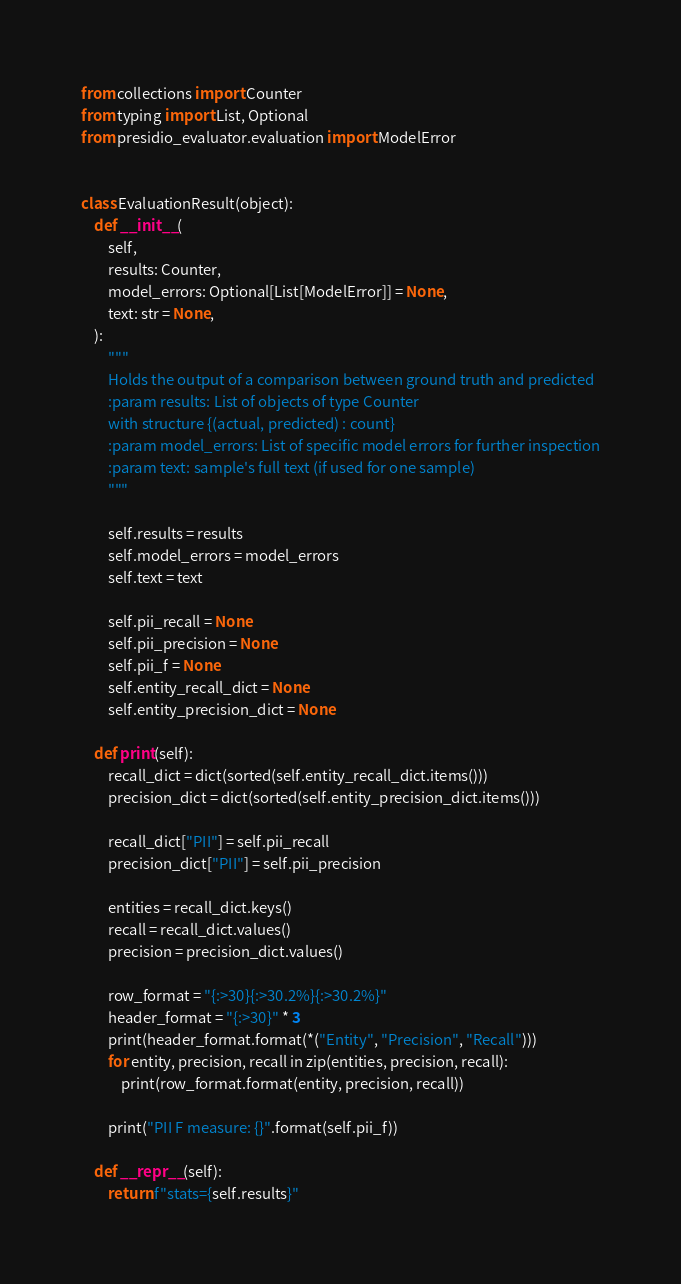Convert code to text. <code><loc_0><loc_0><loc_500><loc_500><_Python_>from collections import Counter
from typing import List, Optional
from presidio_evaluator.evaluation import ModelError


class EvaluationResult(object):
    def __init__(
        self,
        results: Counter,
        model_errors: Optional[List[ModelError]] = None,
        text: str = None,
    ):
        """
        Holds the output of a comparison between ground truth and predicted
        :param results: List of objects of type Counter
        with structure {(actual, predicted) : count}
        :param model_errors: List of specific model errors for further inspection
        :param text: sample's full text (if used for one sample)
        """

        self.results = results
        self.model_errors = model_errors
        self.text = text

        self.pii_recall = None
        self.pii_precision = None
        self.pii_f = None
        self.entity_recall_dict = None
        self.entity_precision_dict = None

    def print(self):
        recall_dict = dict(sorted(self.entity_recall_dict.items()))
        precision_dict = dict(sorted(self.entity_precision_dict.items()))

        recall_dict["PII"] = self.pii_recall
        precision_dict["PII"] = self.pii_precision

        entities = recall_dict.keys()
        recall = recall_dict.values()
        precision = precision_dict.values()

        row_format = "{:>30}{:>30.2%}{:>30.2%}"
        header_format = "{:>30}" * 3
        print(header_format.format(*("Entity", "Precision", "Recall")))
        for entity, precision, recall in zip(entities, precision, recall):
            print(row_format.format(entity, precision, recall))

        print("PII F measure: {}".format(self.pii_f))

    def __repr__(self):
        return f"stats={self.results}"
</code> 